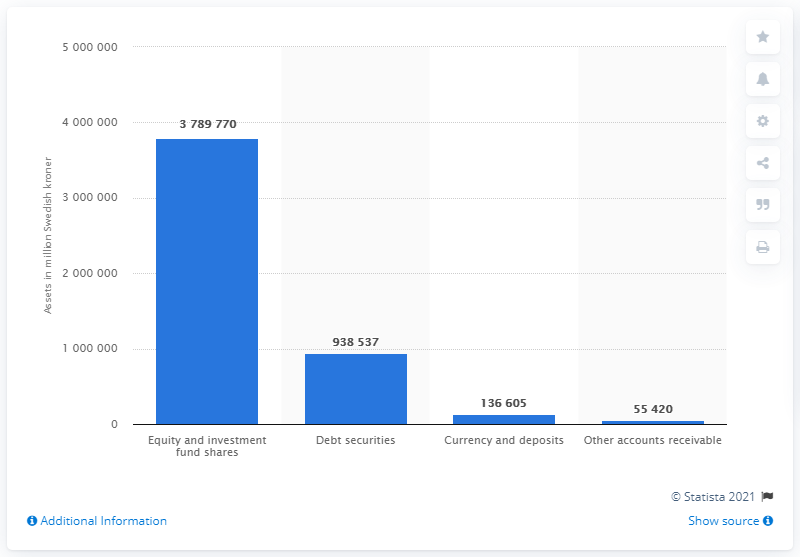Draw attention to some important aspects in this diagram. In 2019, the total value of equity and investment fund shares owned by investment funds was approximately 378,977,000. In 2019, a total of 938,537 Swedish kronor was invested in debt securities. 